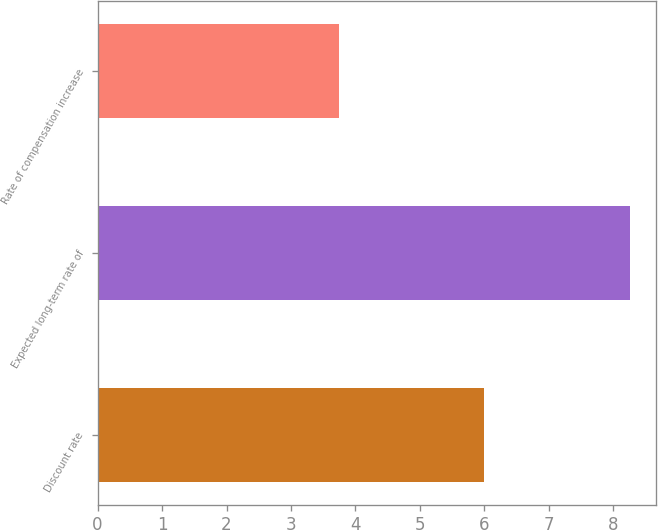<chart> <loc_0><loc_0><loc_500><loc_500><bar_chart><fcel>Discount rate<fcel>Expected long-term rate of<fcel>Rate of compensation increase<nl><fcel>6<fcel>8.25<fcel>3.75<nl></chart> 